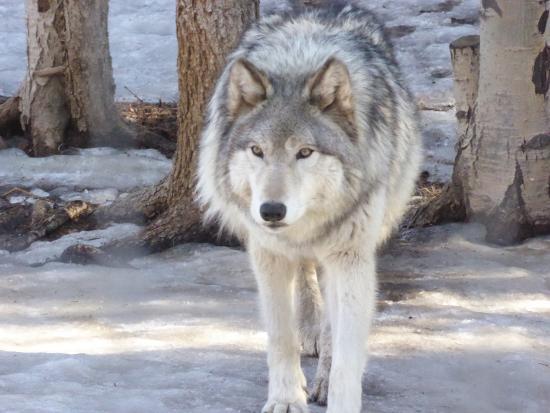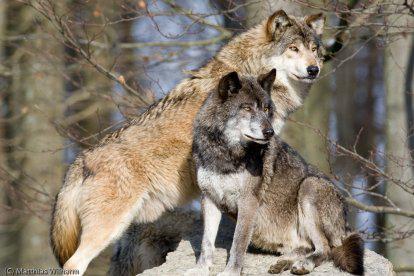The first image is the image on the left, the second image is the image on the right. Examine the images to the left and right. Is the description "There is more than one wolf in the image on the right." accurate? Answer yes or no. Yes. The first image is the image on the left, the second image is the image on the right. Assess this claim about the two images: "The right image contains multiple animals.". Correct or not? Answer yes or no. Yes. 